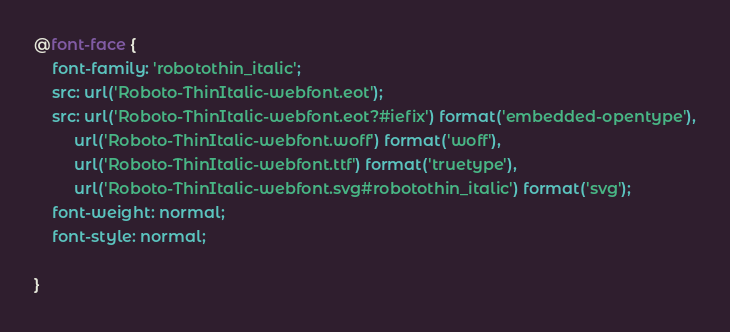<code> <loc_0><loc_0><loc_500><loc_500><_CSS_>@font-face {
    font-family: 'robotothin_italic';
    src: url('Roboto-ThinItalic-webfont.eot');
    src: url('Roboto-ThinItalic-webfont.eot?#iefix') format('embedded-opentype'),
         url('Roboto-ThinItalic-webfont.woff') format('woff'),
         url('Roboto-ThinItalic-webfont.ttf') format('truetype'),
         url('Roboto-ThinItalic-webfont.svg#robotothin_italic') format('svg');
    font-weight: normal;
    font-style: normal;

}

</code> 